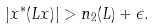Convert formula to latex. <formula><loc_0><loc_0><loc_500><loc_500>| x ^ { * } ( L x ) | > n _ { 2 } ( L ) + \epsilon .</formula> 